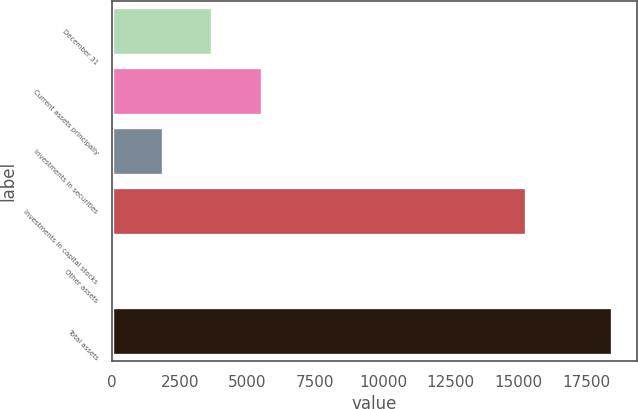Convert chart. <chart><loc_0><loc_0><loc_500><loc_500><bar_chart><fcel>December 31<fcel>Current assets principally<fcel>Investments in securities<fcel>Investments in capital stocks<fcel>Other assets<fcel>Total assets<nl><fcel>3703<fcel>5545<fcel>1861<fcel>15276<fcel>19<fcel>18439<nl></chart> 